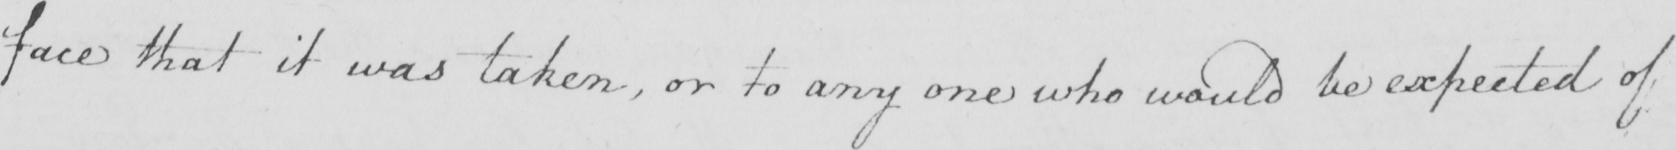Can you tell me what this handwritten text says? face that it was taken , or to any one who would be expected of 